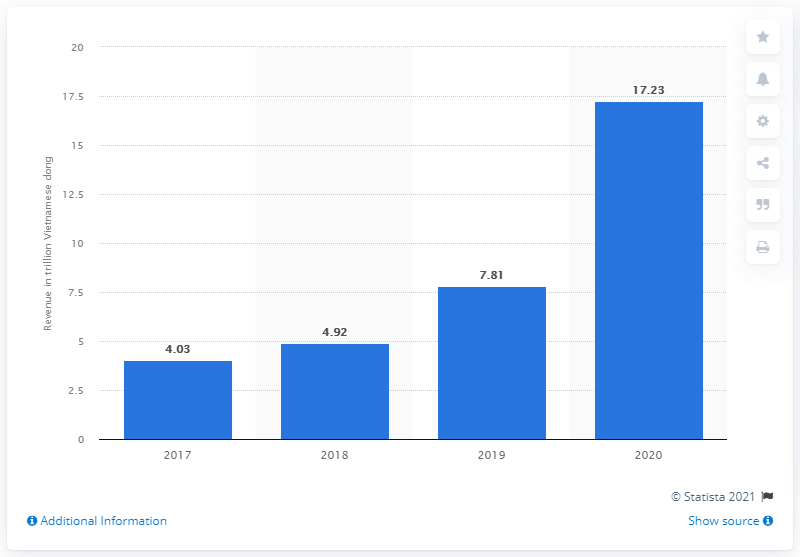Give some essential details in this illustration. Viettel Group's revenue in 2020 was approximately 17.23. 